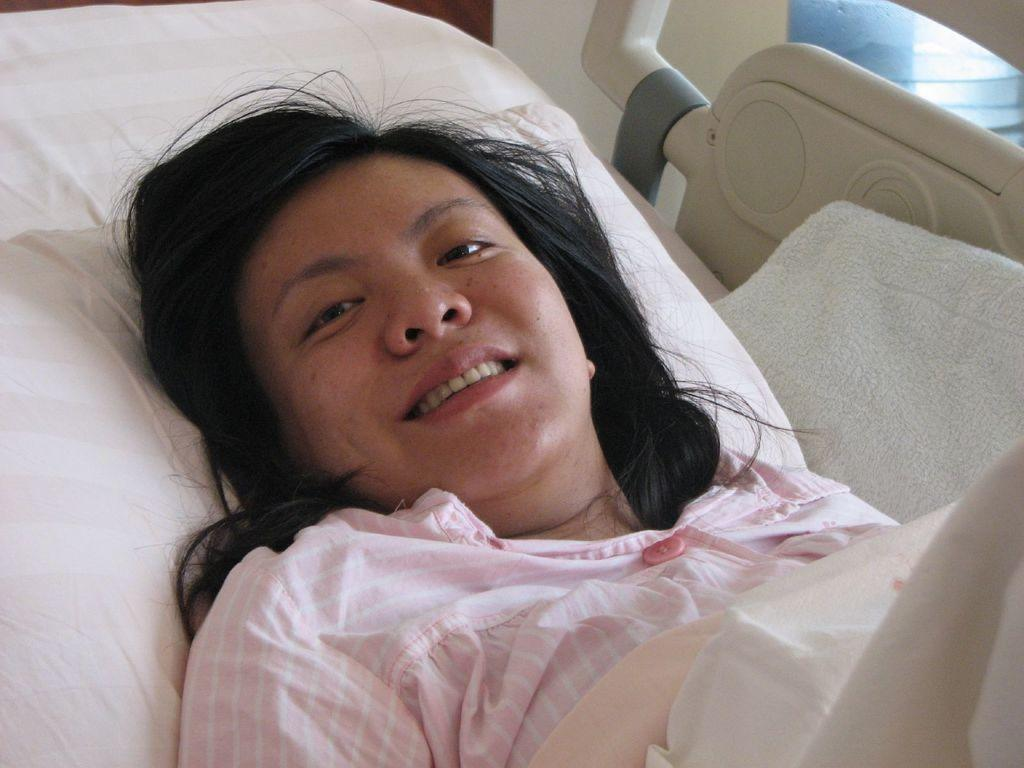What is the main subject of the image? There is a person in the image. What is the person doing in the image? The person is lying on a bed and smiling. What can be seen on the right side of the image? There is a cloth on the right side of the image. How many keys can be seen in the image? There are no keys present in the image. What type of rabbits are visible in the image? There are no rabbits present in the image. 